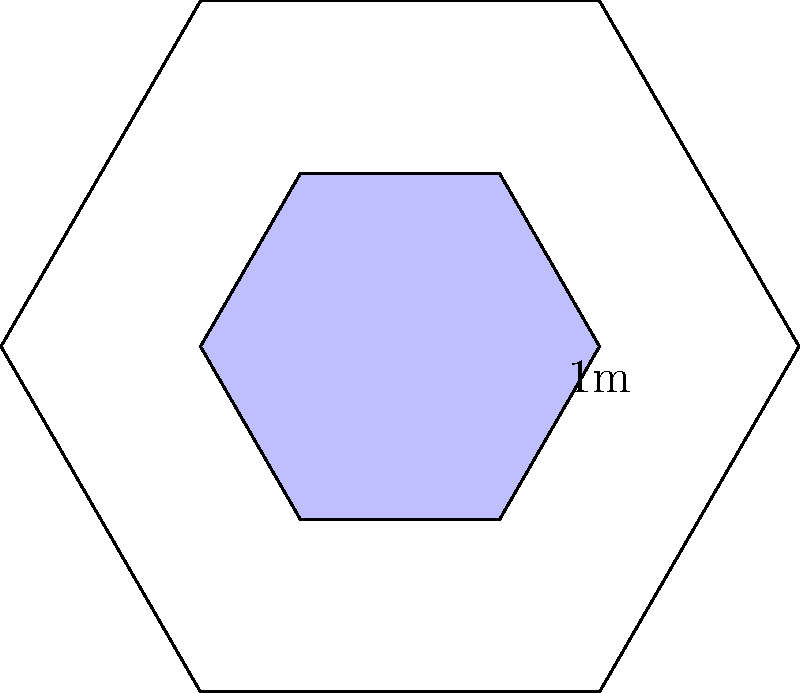As you film the intricate mosaic patterns in St. Vitus Cathedral, you notice a large hexagonal section composed of smaller hexagonal tiles. The large hexagon has a side length of 1 meter, and each smaller hexagon tile has a side length that is exactly half of the large hexagon's side length. How many small hexagonal tiles are needed to completely cover the large hexagonal section? Let's approach this step-by-step:

1) First, we need to calculate the area of the large hexagon:
   Area of a regular hexagon = $\frac{3\sqrt{3}}{2}s^2$, where $s$ is the side length
   Area of large hexagon = $\frac{3\sqrt{3}}{2}(1)^2 = \frac{3\sqrt{3}}{2}$ square meters

2) Now, let's calculate the area of each small hexagonal tile:
   Side length of small hexagon = 0.5 meters
   Area of small hexagon = $\frac{3\sqrt{3}}{2}(0.5)^2 = \frac{3\sqrt{3}}{8}$ square meters

3) To find the number of small hexagons needed, we divide the area of the large hexagon by the area of a small hexagon:

   Number of tiles = $\frac{\text{Area of large hexagon}}{\text{Area of small hexagon}}$
                   = $\frac{\frac{3\sqrt{3}}{2}}{\frac{3\sqrt{3}}{8}}$
                   = $\frac{\frac{3\sqrt{3}}{2} \times \frac{8}{3\sqrt{3}}}$
                   = 4

Therefore, 4 small hexagonal tiles are needed to cover the large hexagonal section.
Answer: 4 tiles 